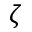Convert formula to latex. <formula><loc_0><loc_0><loc_500><loc_500>\zeta</formula> 